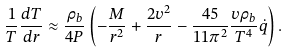<formula> <loc_0><loc_0><loc_500><loc_500>\frac { 1 } { T } \frac { d T } { d r } \approx \frac { \rho _ { b } } { 4 P } \left ( - \frac { M } { r ^ { 2 } } + \frac { 2 v ^ { 2 } } { r } - \frac { 4 5 } { 1 1 \pi ^ { 2 } } \frac { v \rho _ { b } } { T ^ { 4 } } \dot { q } \right ) .</formula> 